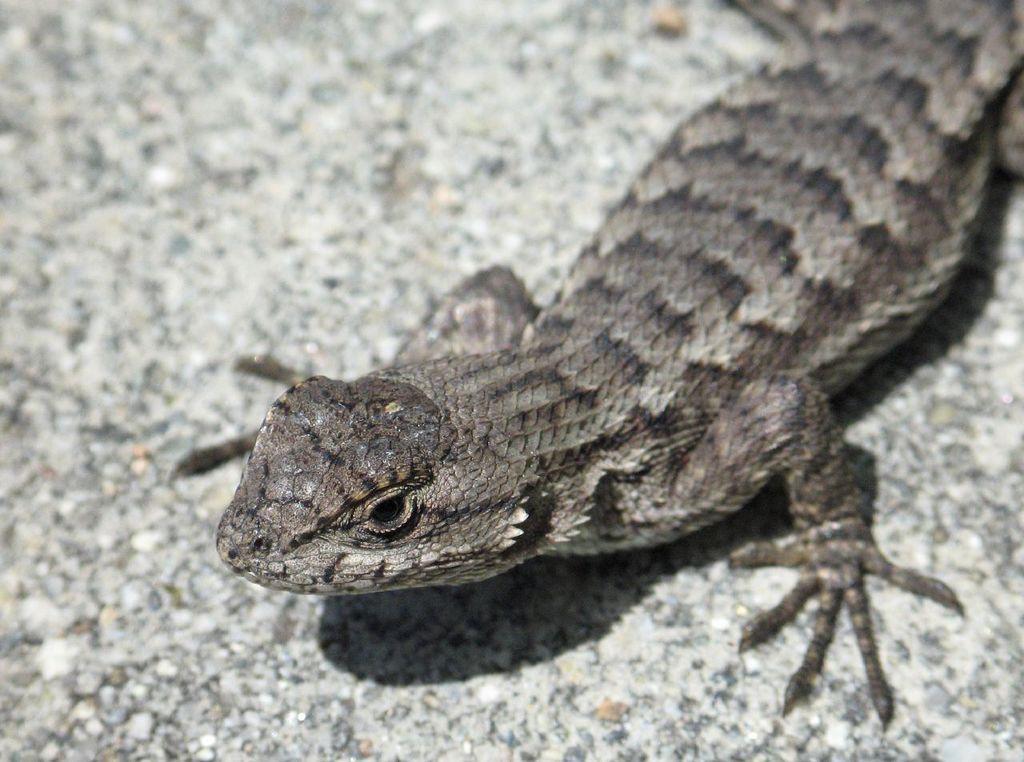How would you summarize this image in a sentence or two? The picture consists of a lizard. 